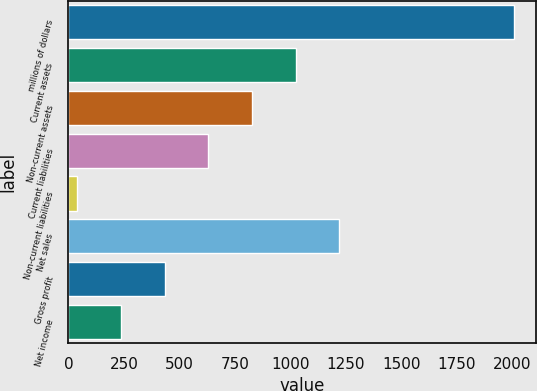Convert chart to OTSL. <chart><loc_0><loc_0><loc_500><loc_500><bar_chart><fcel>millions of dollars<fcel>Current assets<fcel>Non-current assets<fcel>Current liabilities<fcel>Non-current liabilities<fcel>Net sales<fcel>Gross profit<fcel>Net income<nl><fcel>2008<fcel>1024.25<fcel>827.5<fcel>630.75<fcel>40.5<fcel>1221<fcel>434<fcel>237.25<nl></chart> 